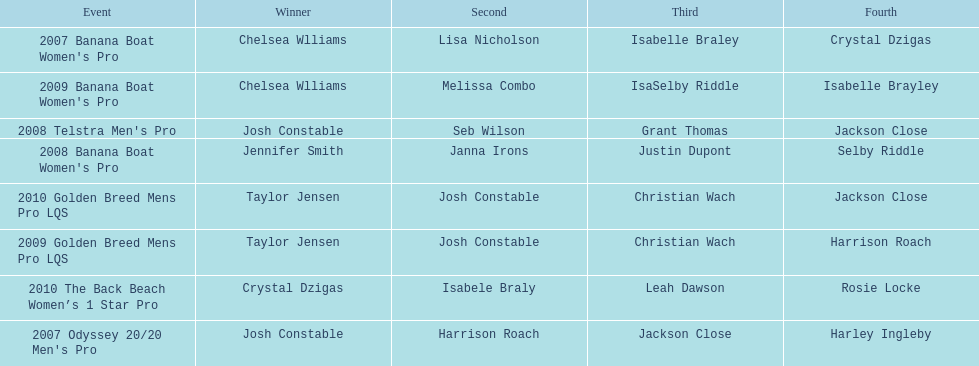Who was the top performer in the 2008 telstra men's pro? Josh Constable. 